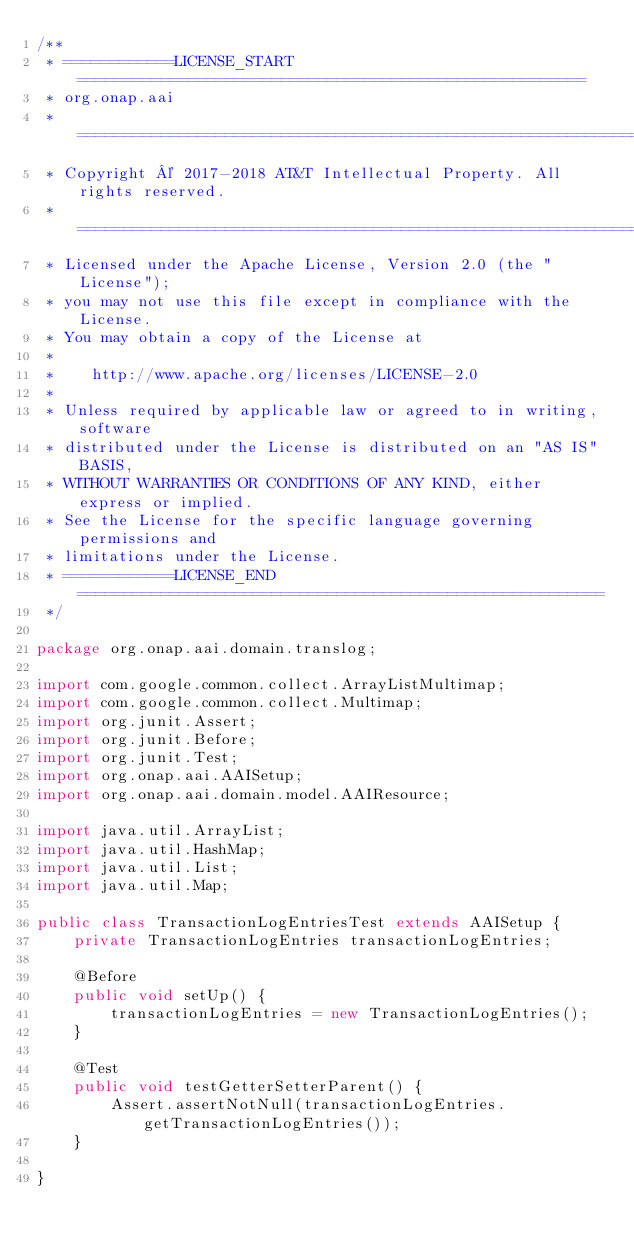Convert code to text. <code><loc_0><loc_0><loc_500><loc_500><_Java_>/**
 * ============LICENSE_START=======================================================
 * org.onap.aai
 * ================================================================================
 * Copyright © 2017-2018 AT&T Intellectual Property. All rights reserved.
 * ================================================================================
 * Licensed under the Apache License, Version 2.0 (the "License");
 * you may not use this file except in compliance with the License.
 * You may obtain a copy of the License at
 *
 *    http://www.apache.org/licenses/LICENSE-2.0
 *
 * Unless required by applicable law or agreed to in writing, software
 * distributed under the License is distributed on an "AS IS" BASIS,
 * WITHOUT WARRANTIES OR CONDITIONS OF ANY KIND, either express or implied.
 * See the License for the specific language governing permissions and
 * limitations under the License.
 * ============LICENSE_END=========================================================
 */

package org.onap.aai.domain.translog;

import com.google.common.collect.ArrayListMultimap;
import com.google.common.collect.Multimap;
import org.junit.Assert;
import org.junit.Before;
import org.junit.Test;
import org.onap.aai.AAISetup;
import org.onap.aai.domain.model.AAIResource;

import java.util.ArrayList;
import java.util.HashMap;
import java.util.List;
import java.util.Map;

public class TransactionLogEntriesTest extends AAISetup {
    private TransactionLogEntries transactionLogEntries;

    @Before
    public void setUp() {
        transactionLogEntries = new TransactionLogEntries();
    }

    @Test
    public void testGetterSetterParent() {
        Assert.assertNotNull(transactionLogEntries.getTransactionLogEntries());
    }

}
</code> 